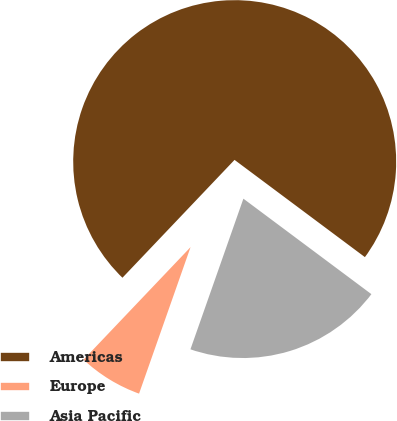Convert chart to OTSL. <chart><loc_0><loc_0><loc_500><loc_500><pie_chart><fcel>Americas<fcel>Europe<fcel>Asia Pacific<nl><fcel>73.1%<fcel>6.72%<fcel>20.18%<nl></chart> 